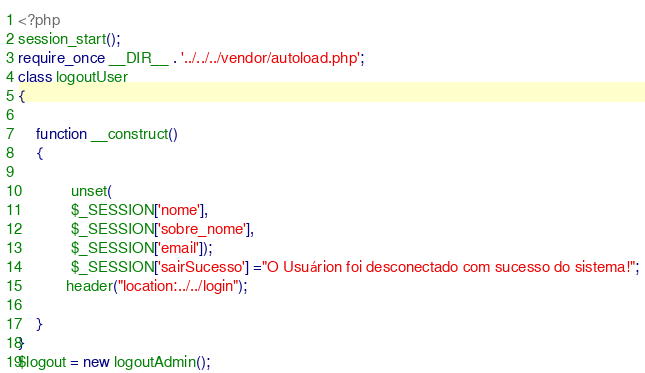Convert code to text. <code><loc_0><loc_0><loc_500><loc_500><_PHP_><?php
session_start();
require_once __DIR__ . '../../../vendor/autoload.php';
class logoutUser
{

    function __construct()
    {
       
            unset(
            $_SESSION['nome'],
            $_SESSION['sobre_nome'],
            $_SESSION['email']);
            $_SESSION['sairSucesso'] ="O Usuárion foi desconectado com sucesso do sistema!";
           header("location:../../login");
        
    }
}
$logout = new logoutAdmin();
</code> 